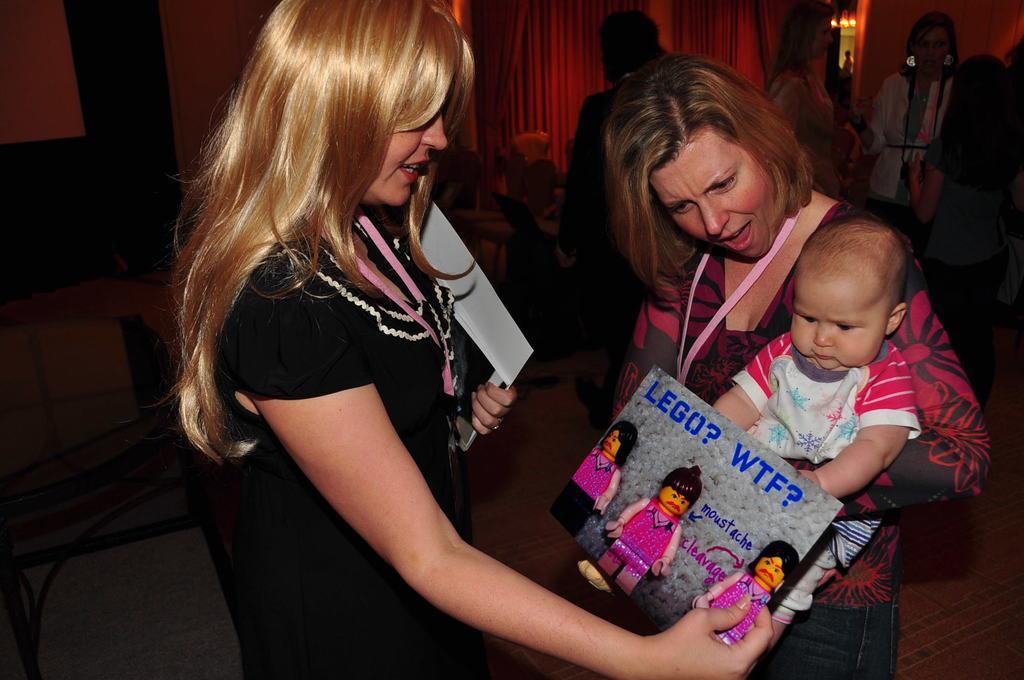Can you describe this image briefly? In this image in the foreground there are two women standing, and one woman is holding a baby and one woman is holding some books. And in the background there are a group of people standing and also there are some chairs, curtains and wall. At the bottom there is floor, and on the left side there is one table. 